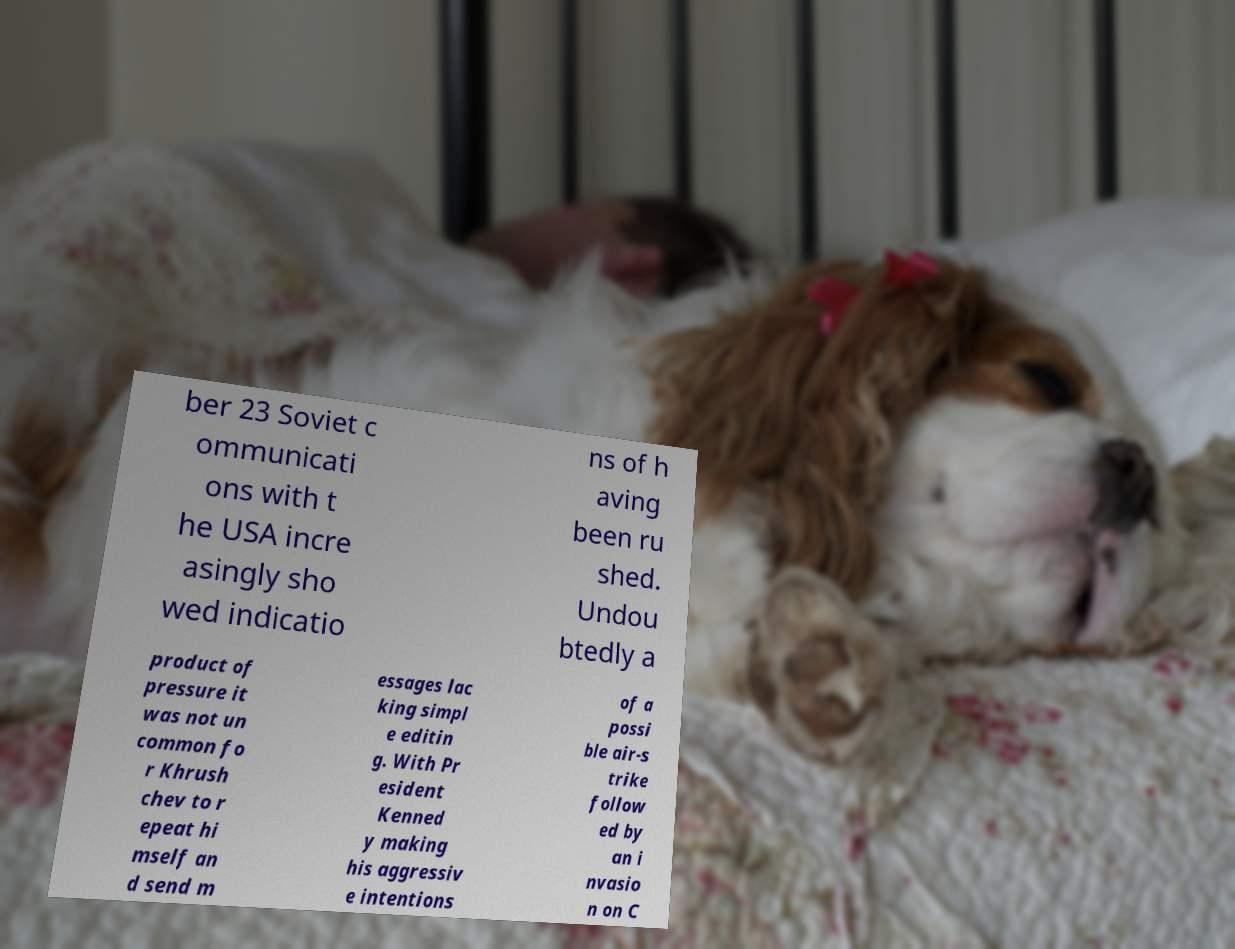What messages or text are displayed in this image? I need them in a readable, typed format. ber 23 Soviet c ommunicati ons with t he USA incre asingly sho wed indicatio ns of h aving been ru shed. Undou btedly a product of pressure it was not un common fo r Khrush chev to r epeat hi mself an d send m essages lac king simpl e editin g. With Pr esident Kenned y making his aggressiv e intentions of a possi ble air-s trike follow ed by an i nvasio n on C 